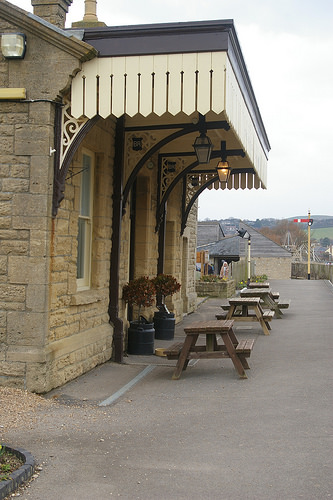<image>
Is the lamp above the chair? Yes. The lamp is positioned above the chair in the vertical space, higher up in the scene. 